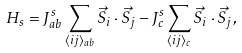Convert formula to latex. <formula><loc_0><loc_0><loc_500><loc_500>H _ { s } = J _ { a b } ^ { s } \sum _ { \langle i j \rangle _ { a b } } \vec { S } _ { i } \cdot \vec { S } _ { j } - J _ { c } ^ { s } \sum _ { \langle i j \rangle _ { c } } \vec { S } _ { i } \cdot \vec { S } _ { j } ,</formula> 